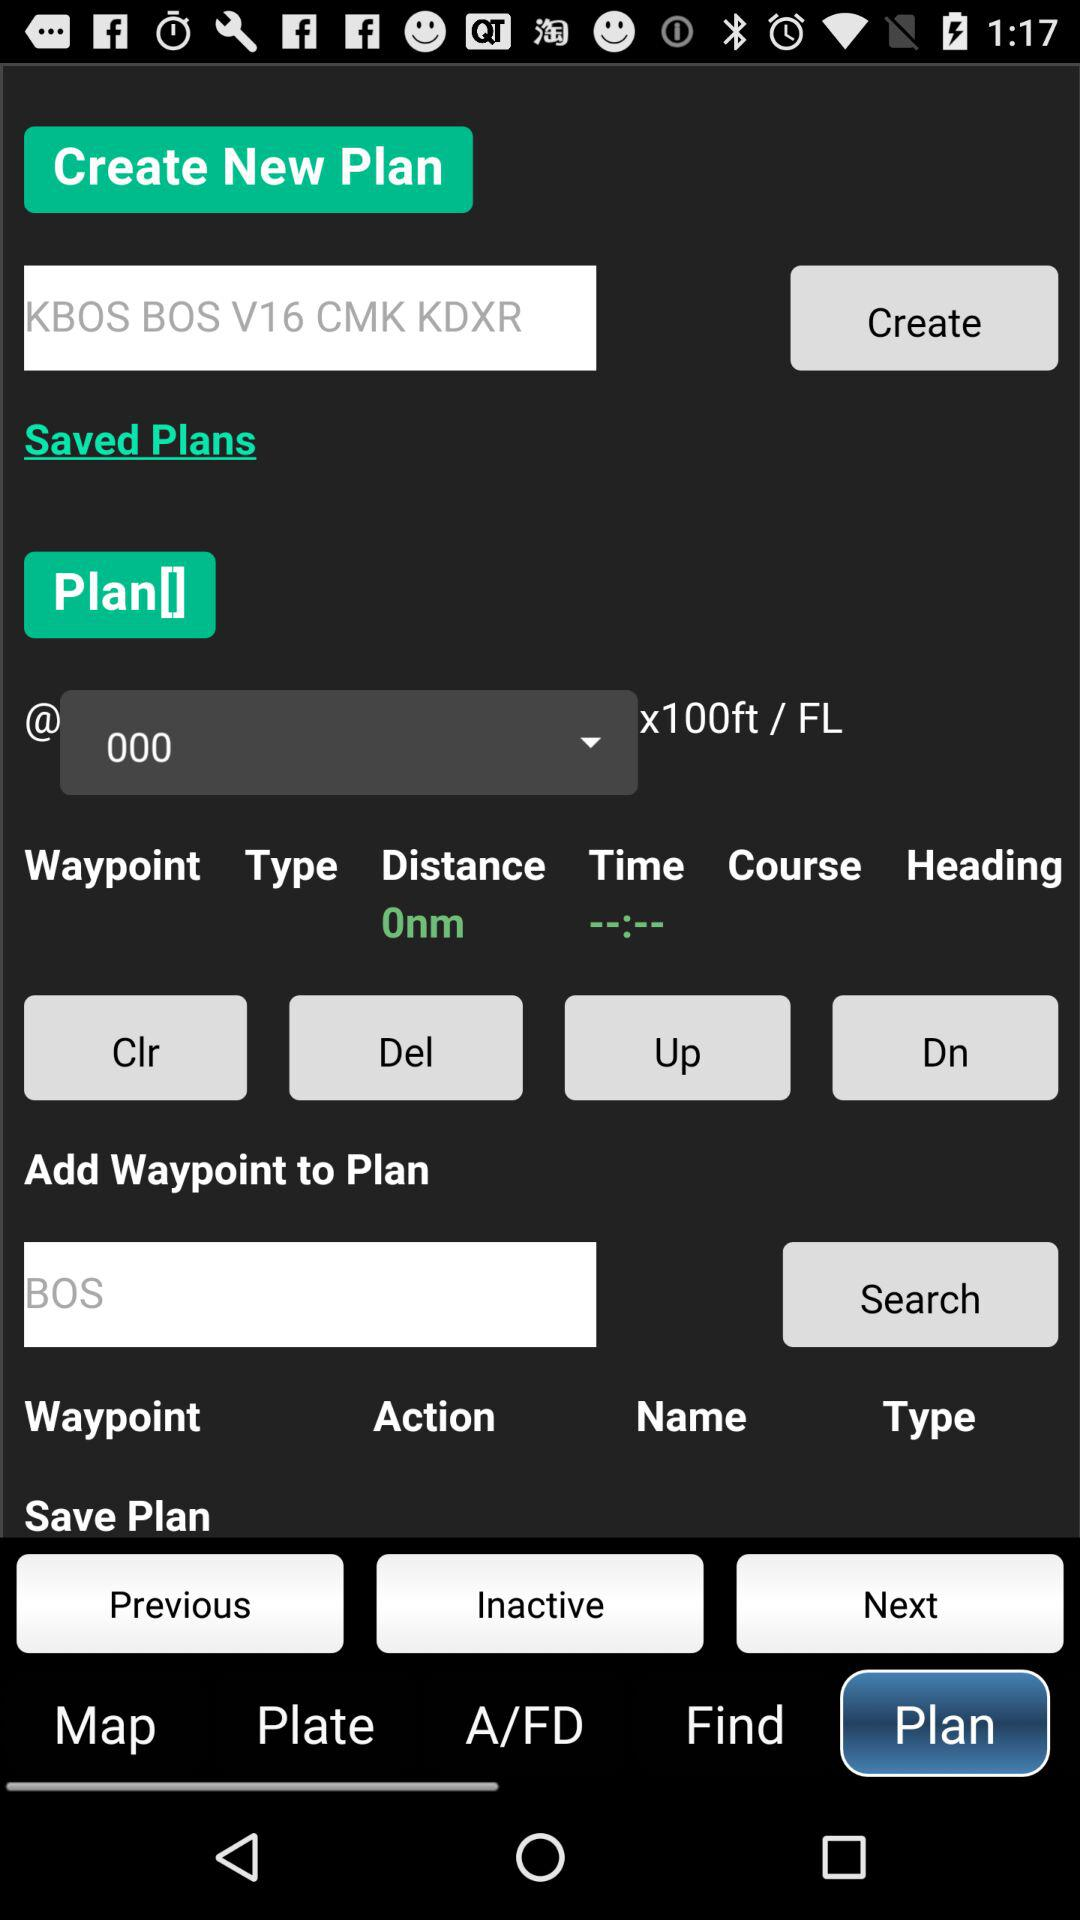Which tab am I using? The tab is "Plan". 